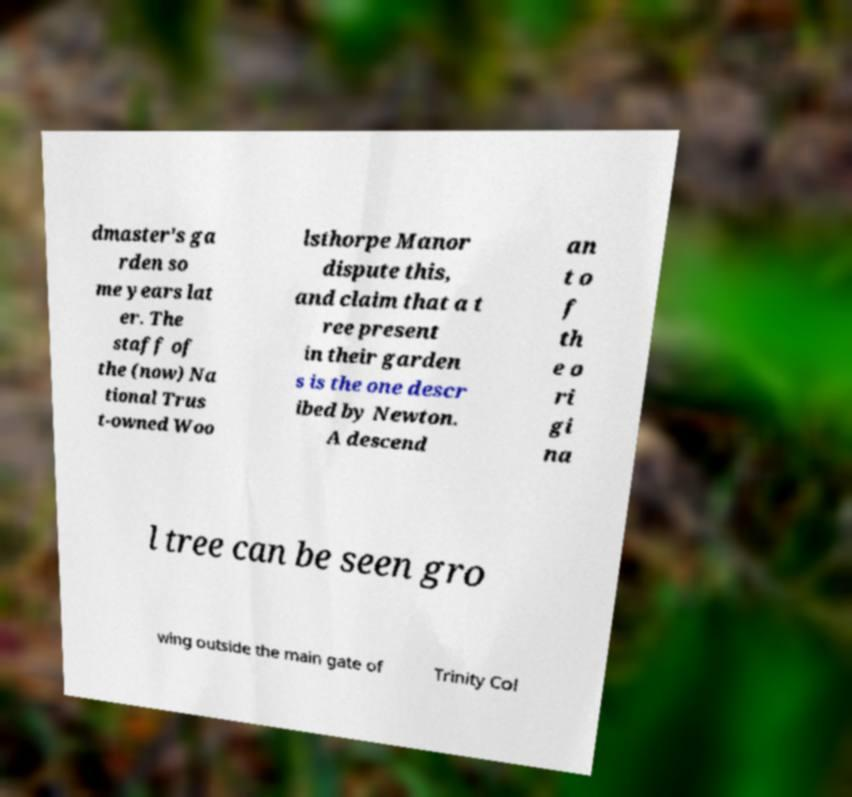I need the written content from this picture converted into text. Can you do that? dmaster's ga rden so me years lat er. The staff of the (now) Na tional Trus t-owned Woo lsthorpe Manor dispute this, and claim that a t ree present in their garden s is the one descr ibed by Newton. A descend an t o f th e o ri gi na l tree can be seen gro wing outside the main gate of Trinity Col 